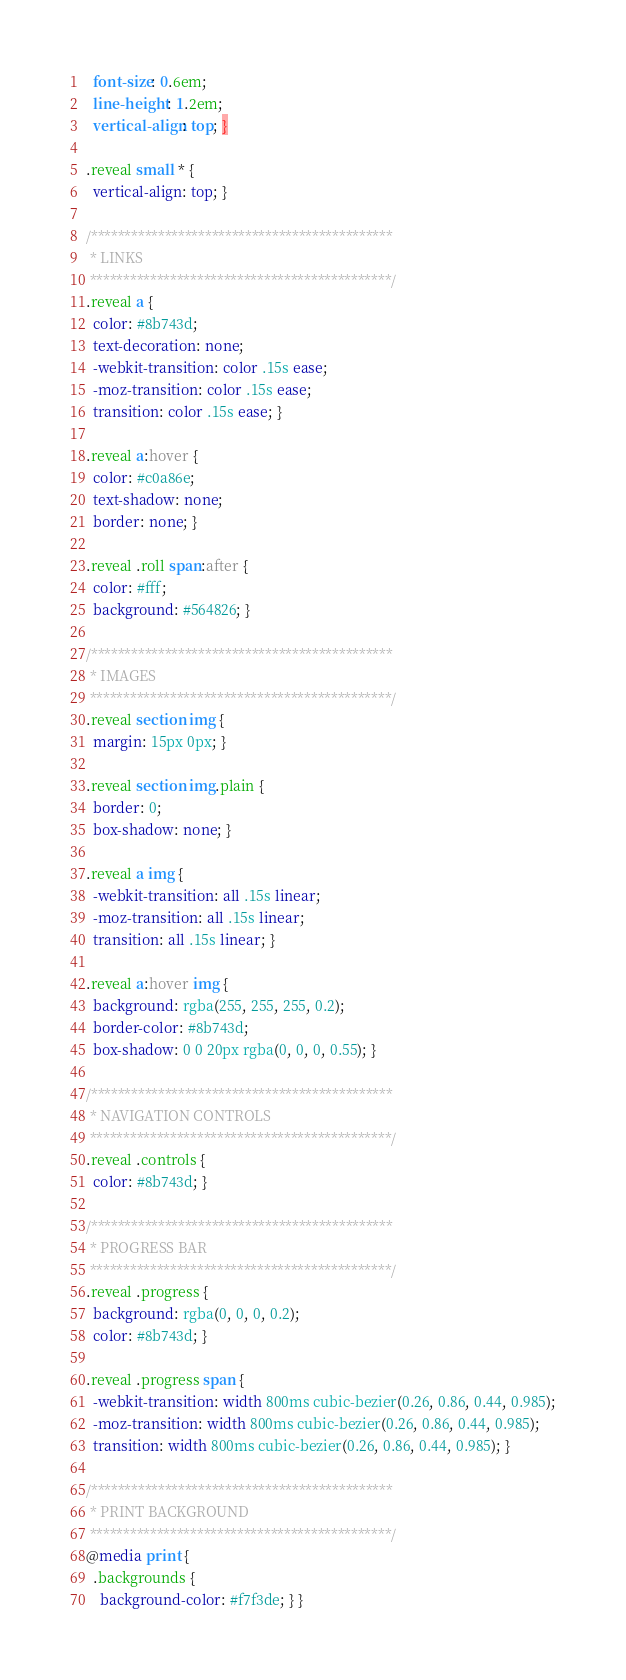Convert code to text. <code><loc_0><loc_0><loc_500><loc_500><_CSS_>  font-size: 0.6em;
  line-height: 1.2em;
  vertical-align: top; }

.reveal small * {
  vertical-align: top; }

/*********************************************
 * LINKS
 *********************************************/
.reveal a {
  color: #8b743d;
  text-decoration: none;
  -webkit-transition: color .15s ease;
  -moz-transition: color .15s ease;
  transition: color .15s ease; }

.reveal a:hover {
  color: #c0a86e;
  text-shadow: none;
  border: none; }

.reveal .roll span:after {
  color: #fff;
  background: #564826; }

/*********************************************
 * IMAGES
 *********************************************/
.reveal section img {
  margin: 15px 0px; }

.reveal section img.plain {
  border: 0;
  box-shadow: none; }

.reveal a img {
  -webkit-transition: all .15s linear;
  -moz-transition: all .15s linear;
  transition: all .15s linear; }

.reveal a:hover img {
  background: rgba(255, 255, 255, 0.2);
  border-color: #8b743d;
  box-shadow: 0 0 20px rgba(0, 0, 0, 0.55); }

/*********************************************
 * NAVIGATION CONTROLS
 *********************************************/
.reveal .controls {
  color: #8b743d; }

/*********************************************
 * PROGRESS BAR
 *********************************************/
.reveal .progress {
  background: rgba(0, 0, 0, 0.2);
  color: #8b743d; }

.reveal .progress span {
  -webkit-transition: width 800ms cubic-bezier(0.26, 0.86, 0.44, 0.985);
  -moz-transition: width 800ms cubic-bezier(0.26, 0.86, 0.44, 0.985);
  transition: width 800ms cubic-bezier(0.26, 0.86, 0.44, 0.985); }

/*********************************************
 * PRINT BACKGROUND
 *********************************************/
@media print {
  .backgrounds {
    background-color: #f7f3de; } }
</code> 